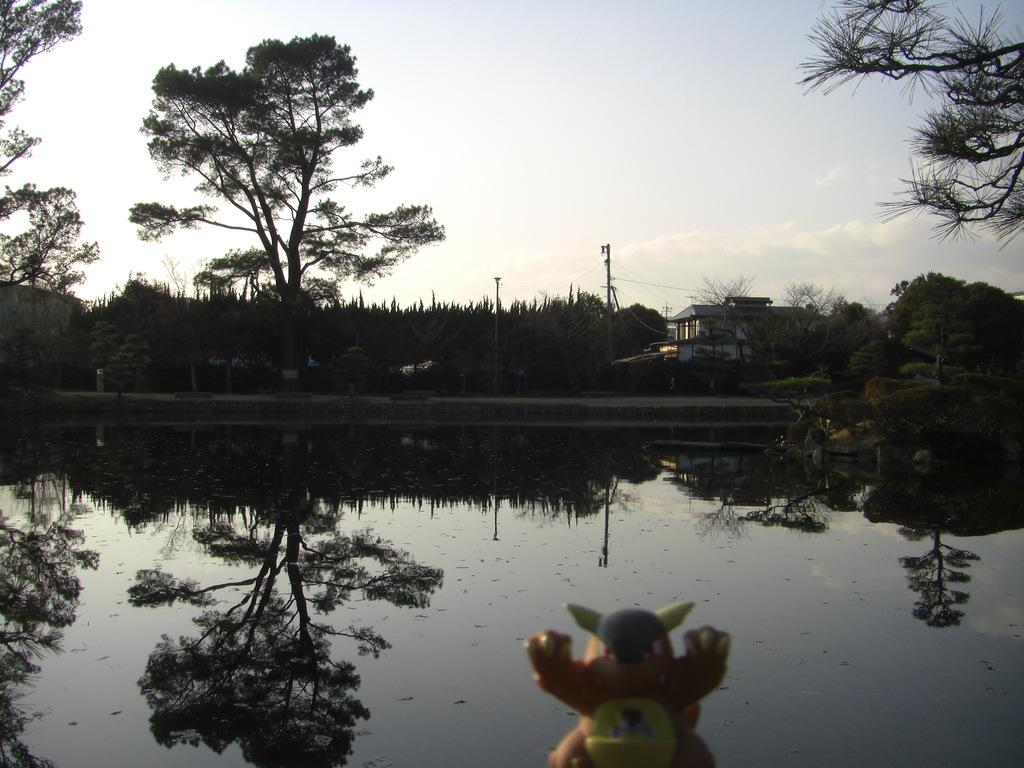What type of water body is visible in the image? The image contains a water body, but the specific type is not mentioned. What else can be seen in the image besides the water body? There is a group of plants, a building, poles and wires, and a toy in the foreground of the image. Can you describe the sky in the image? The sky is visible in the image and appears cloudy. What type of destruction can be seen in the image? There is no destruction present in the image. What angle is the image taken from? The angle from which the image is taken is not mentioned in the provided facts. 